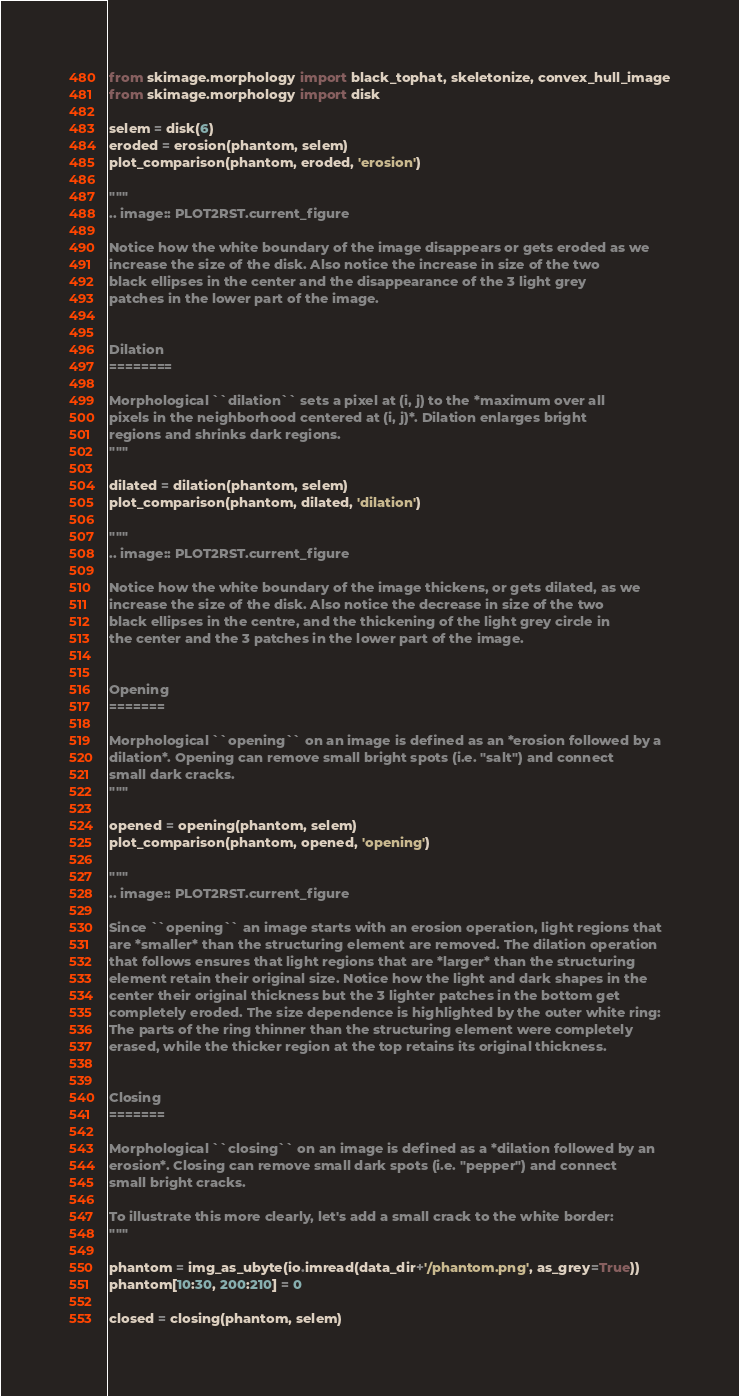Convert code to text. <code><loc_0><loc_0><loc_500><loc_500><_Python_>from skimage.morphology import black_tophat, skeletonize, convex_hull_image
from skimage.morphology import disk

selem = disk(6)
eroded = erosion(phantom, selem)
plot_comparison(phantom, eroded, 'erosion')

"""
.. image:: PLOT2RST.current_figure

Notice how the white boundary of the image disappears or gets eroded as we
increase the size of the disk. Also notice the increase in size of the two
black ellipses in the center and the disappearance of the 3 light grey
patches in the lower part of the image.


Dilation
========

Morphological ``dilation`` sets a pixel at (i, j) to the *maximum over all
pixels in the neighborhood centered at (i, j)*. Dilation enlarges bright
regions and shrinks dark regions.
"""

dilated = dilation(phantom, selem)
plot_comparison(phantom, dilated, 'dilation')

"""
.. image:: PLOT2RST.current_figure

Notice how the white boundary of the image thickens, or gets dilated, as we
increase the size of the disk. Also notice the decrease in size of the two
black ellipses in the centre, and the thickening of the light grey circle in
the center and the 3 patches in the lower part of the image.


Opening
=======

Morphological ``opening`` on an image is defined as an *erosion followed by a
dilation*. Opening can remove small bright spots (i.e. "salt") and connect
small dark cracks.
"""

opened = opening(phantom, selem)
plot_comparison(phantom, opened, 'opening')

"""
.. image:: PLOT2RST.current_figure

Since ``opening`` an image starts with an erosion operation, light regions that
are *smaller* than the structuring element are removed. The dilation operation
that follows ensures that light regions that are *larger* than the structuring
element retain their original size. Notice how the light and dark shapes in the
center their original thickness but the 3 lighter patches in the bottom get
completely eroded. The size dependence is highlighted by the outer white ring:
The parts of the ring thinner than the structuring element were completely
erased, while the thicker region at the top retains its original thickness.


Closing
=======

Morphological ``closing`` on an image is defined as a *dilation followed by an
erosion*. Closing can remove small dark spots (i.e. "pepper") and connect
small bright cracks.

To illustrate this more clearly, let's add a small crack to the white border:
"""

phantom = img_as_ubyte(io.imread(data_dir+'/phantom.png', as_grey=True))
phantom[10:30, 200:210] = 0

closed = closing(phantom, selem)</code> 